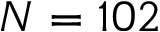<formula> <loc_0><loc_0><loc_500><loc_500>N = 1 0 2</formula> 